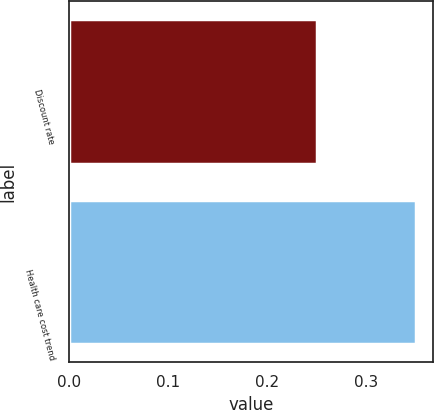<chart> <loc_0><loc_0><loc_500><loc_500><bar_chart><fcel>Discount rate<fcel>Health care cost trend<nl><fcel>0.25<fcel>0.35<nl></chart> 